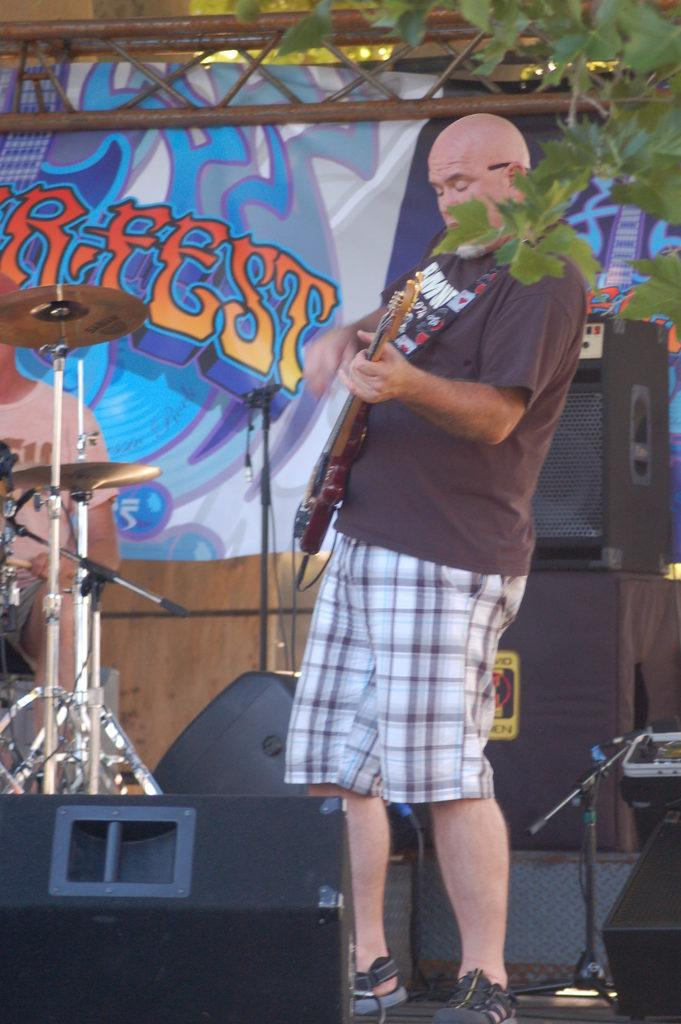What is the man in the image doing? The man is playing a guitar in the image. What else can be seen in the image related to music? There are other musical instruments in the image. What is present in the background of the image? There is a loudspeaker and a plant in the background of the image. What time of day is it in the image, and what sport is being played? The provided facts do not mention the time of day or any sports being played in the image. 